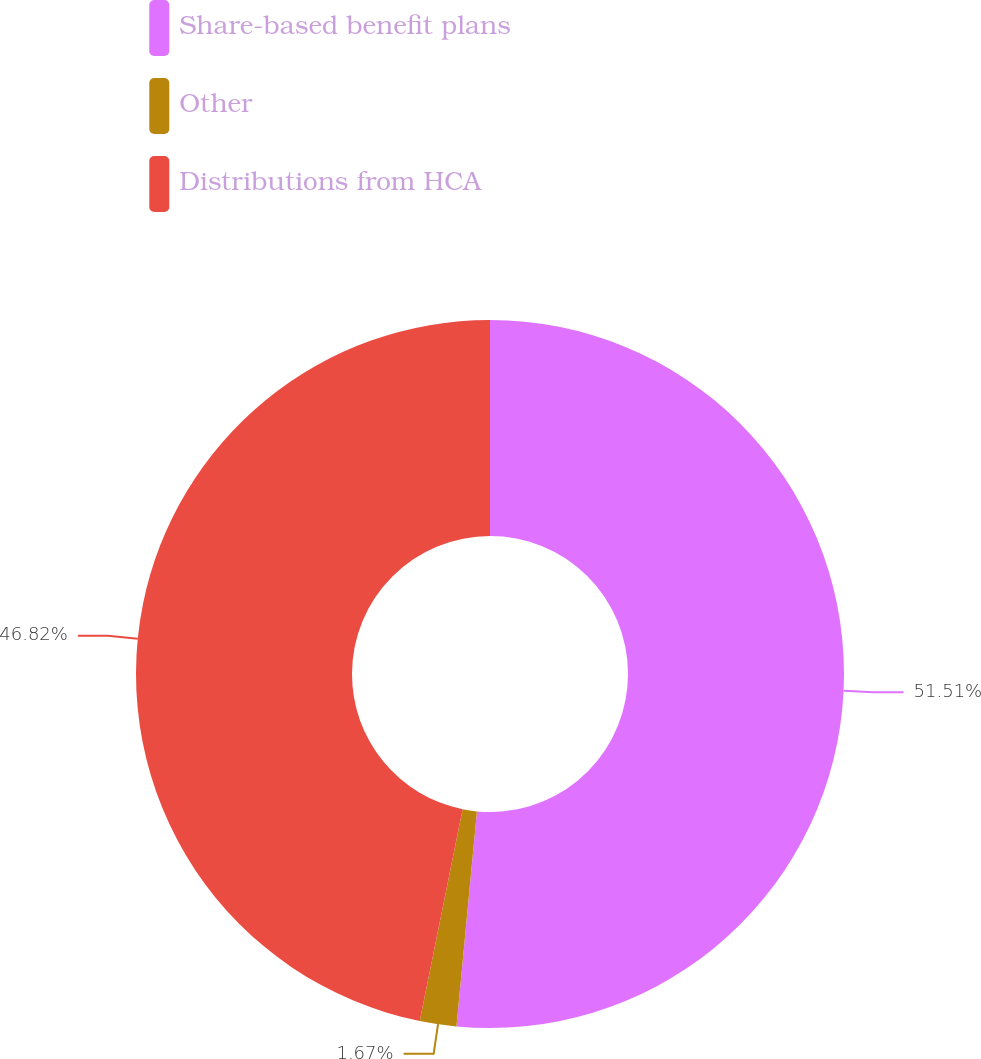Convert chart. <chart><loc_0><loc_0><loc_500><loc_500><pie_chart><fcel>Share-based benefit plans<fcel>Other<fcel>Distributions from HCA<nl><fcel>51.51%<fcel>1.67%<fcel>46.82%<nl></chart> 